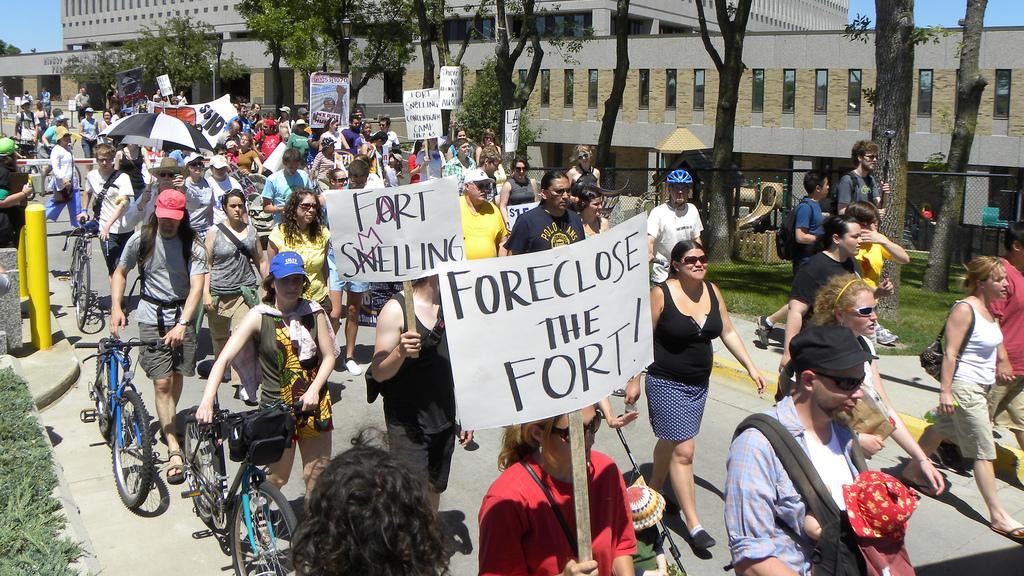Please provide a concise description of this image. In this image we can see few buildings. There is a sky at the left side of the image. There are many people walking on the road and holding some objects in their hands. There are few vehicles in the image. There are many trees and plants in the image. There is a grassy land in the image. 